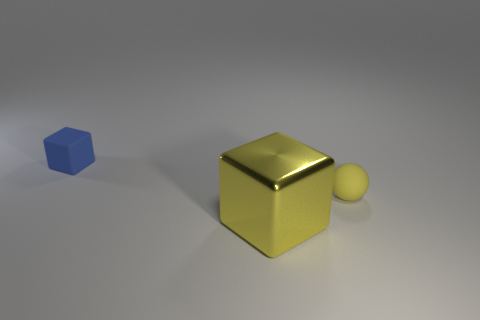Add 3 small blue things. How many objects exist? 6 Subtract all blocks. How many objects are left? 1 Subtract all large yellow shiny cubes. Subtract all small yellow shiny objects. How many objects are left? 2 Add 3 large yellow metallic things. How many large yellow metallic things are left? 4 Add 2 cylinders. How many cylinders exist? 2 Subtract 0 red spheres. How many objects are left? 3 